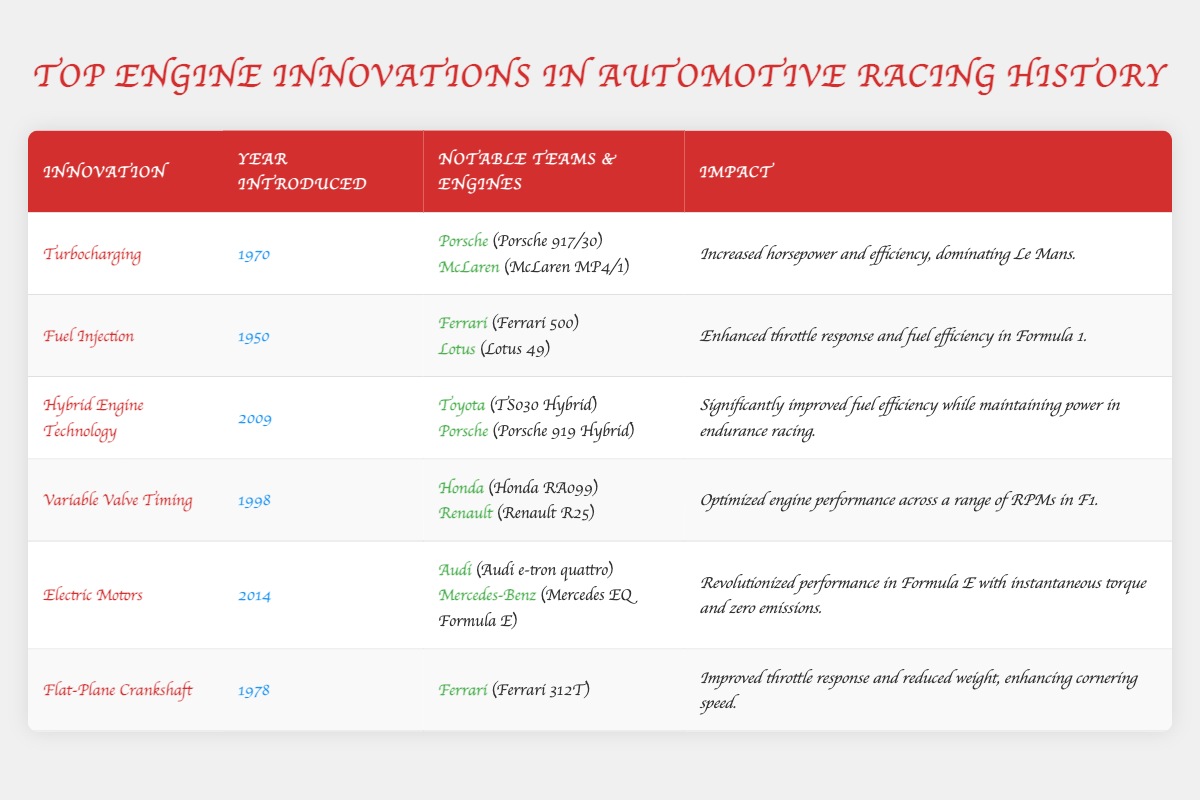What was the first year fuel injection was introduced? The table lists fuel injection with the year introduced as 1950.
Answer: 1950 Which team used the flat-plane crankshaft innovation? The table shows that Ferrari used the flat-plane crankshaft in the Ferrari 312T.
Answer: Ferrari What impact did turbocharging have on racing? The impact of turbocharging as listed in the table states it increased horsepower and efficiency, dominating Le Mans.
Answer: Increased horsepower and efficiency, dominating Le Mans Which engine technology was introduced in 2009? The table shows that hybrid engine technology was introduced in 2009.
Answer: Hybrid Engine Technology How many notable teams are listed for electric motors? The table shows two notable teams listed for electric motors: Audi and Mercedes-Benz.
Answer: Two teams Which innovation was first introduced in 1998? The table indicates that variable valve timing was first introduced in 1998.
Answer: Variable Valve Timing Is there an engine from Porsche mentioned in the innovation of turbocharging? Yes, the table lists the Porsche 917/30 as associated with turbocharging.
Answer: Yes What innovation had the impact of optimizing engine performance across a range of RPMs? The table identifies variable valve timing as having the impact of optimizing engine performance across a range of RPMs.
Answer: Variable Valve Timing Which team had an engine with the impact of revolutionizing performance in Formula E? The table indicates that Audi (with the Audi e-tron quattro) and Mercedes-Benz (with the Mercedes EQ Formula E) revolutionized performance in Formula E.
Answer: Audi and Mercedes-Benz Calculate the difference in years introduced between turbocharging and electric motors. Turbocharging was introduced in 1970 and electric motors in 2014. The difference is 2014 - 1970 = 44 years.
Answer: 44 years What was the impact of hybrid engine technology? The table states the impact of hybrid engine technology was significantly improved fuel efficiency while maintaining power in endurance racing.
Answer: Improved fuel efficiency while maintaining power Was the Ferrari 500 associated with fuel injection? Yes, according to the table, the Ferrari 500 is listed under notable teams for fuel injection.
Answer: Yes What notable teams used flat-plane crankshaft technology? The table shows that only Ferrari is listed as using flat-plane crankshaft technology with the Ferrari 312T.
Answer: Ferrari Which innovation had the latest introduction year according to the table? Electric motors have the latest introduction year in 2014 as per the table.
Answer: Electric Motors Name the two engines associated with hybrid engine technology. The table mentions the Toyota TS030 Hybrid and the Porsche 919 Hybrid as associated with hybrid engine technology.
Answer: Toyota TS030 Hybrid and Porsche 919 Hybrid 